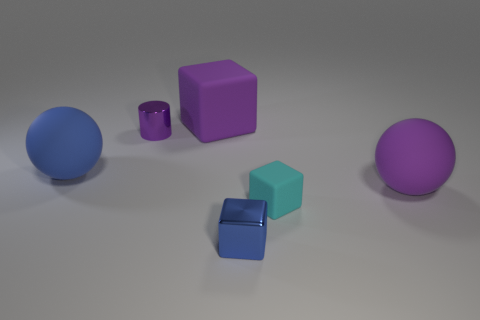Do the purple cylinder that is left of the purple block and the large block have the same size?
Your answer should be compact. No. Is there any other thing that has the same color as the tiny matte cube?
Ensure brevity in your answer.  No. The blue metal object is what shape?
Offer a terse response. Cube. How many big balls are both on the right side of the shiny cylinder and to the left of the cyan matte object?
Provide a succinct answer. 0. Is the tiny rubber object the same color as the tiny metallic cylinder?
Your answer should be compact. No. There is another large thing that is the same shape as the large blue rubber object; what is it made of?
Keep it short and to the point. Rubber. Are there any other things that have the same material as the big blue ball?
Give a very brief answer. Yes. Are there an equal number of rubber cubes that are left of the small purple object and blocks that are on the left side of the tiny matte block?
Offer a very short reply. No. Is the material of the small cyan thing the same as the big blue ball?
Offer a terse response. Yes. How many gray things are either small cylinders or large blocks?
Your response must be concise. 0. 